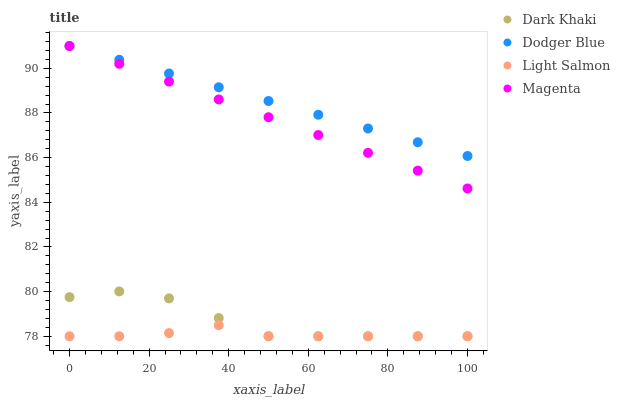Does Light Salmon have the minimum area under the curve?
Answer yes or no. Yes. Does Dodger Blue have the maximum area under the curve?
Answer yes or no. Yes. Does Dodger Blue have the minimum area under the curve?
Answer yes or no. No. Does Light Salmon have the maximum area under the curve?
Answer yes or no. No. Is Magenta the smoothest?
Answer yes or no. Yes. Is Dark Khaki the roughest?
Answer yes or no. Yes. Is Light Salmon the smoothest?
Answer yes or no. No. Is Light Salmon the roughest?
Answer yes or no. No. Does Dark Khaki have the lowest value?
Answer yes or no. Yes. Does Dodger Blue have the lowest value?
Answer yes or no. No. Does Magenta have the highest value?
Answer yes or no. Yes. Does Light Salmon have the highest value?
Answer yes or no. No. Is Light Salmon less than Dodger Blue?
Answer yes or no. Yes. Is Magenta greater than Light Salmon?
Answer yes or no. Yes. Does Light Salmon intersect Dark Khaki?
Answer yes or no. Yes. Is Light Salmon less than Dark Khaki?
Answer yes or no. No. Is Light Salmon greater than Dark Khaki?
Answer yes or no. No. Does Light Salmon intersect Dodger Blue?
Answer yes or no. No. 